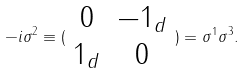<formula> <loc_0><loc_0><loc_500><loc_500>- i \sigma ^ { 2 } \equiv ( \begin{array} { c c } 0 & - 1 _ { d } \\ 1 _ { d } & 0 \end{array} ) = \sigma ^ { 1 } \sigma ^ { 3 } .</formula> 